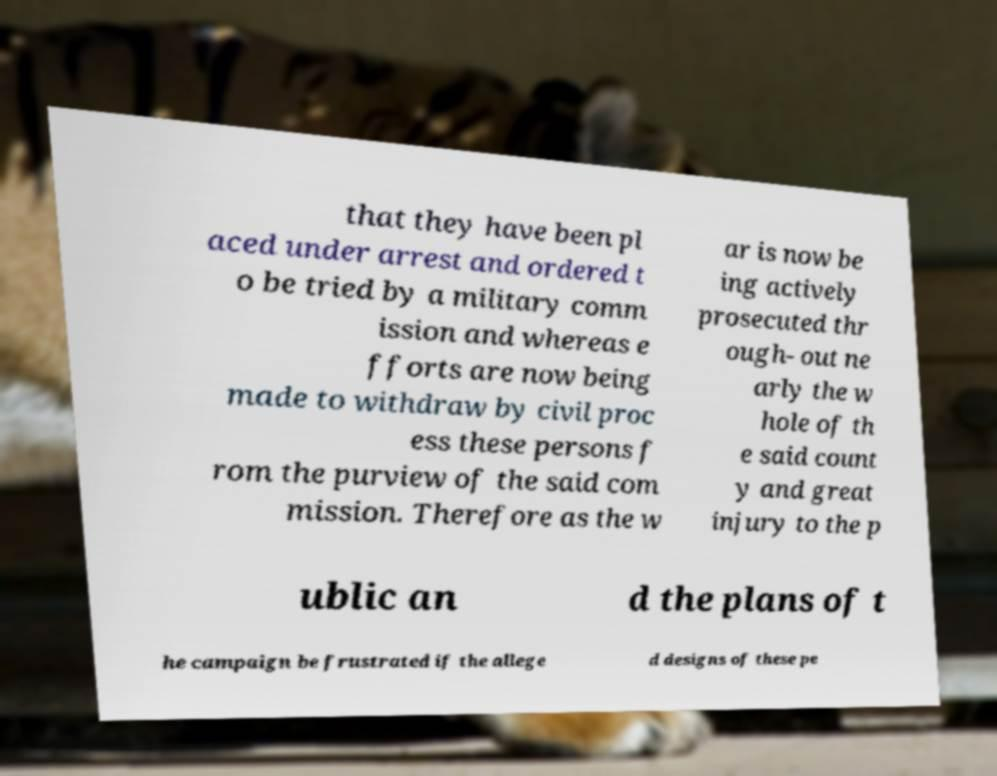For documentation purposes, I need the text within this image transcribed. Could you provide that? that they have been pl aced under arrest and ordered t o be tried by a military comm ission and whereas e fforts are now being made to withdraw by civil proc ess these persons f rom the purview of the said com mission. Therefore as the w ar is now be ing actively prosecuted thr ough- out ne arly the w hole of th e said count y and great injury to the p ublic an d the plans of t he campaign be frustrated if the allege d designs of these pe 